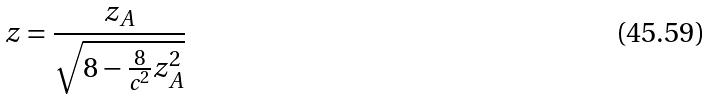<formula> <loc_0><loc_0><loc_500><loc_500>z = \frac { z _ { A } } { \sqrt { 8 - \frac { 8 } { c ^ { 2 } } z _ { A } ^ { 2 } } }</formula> 